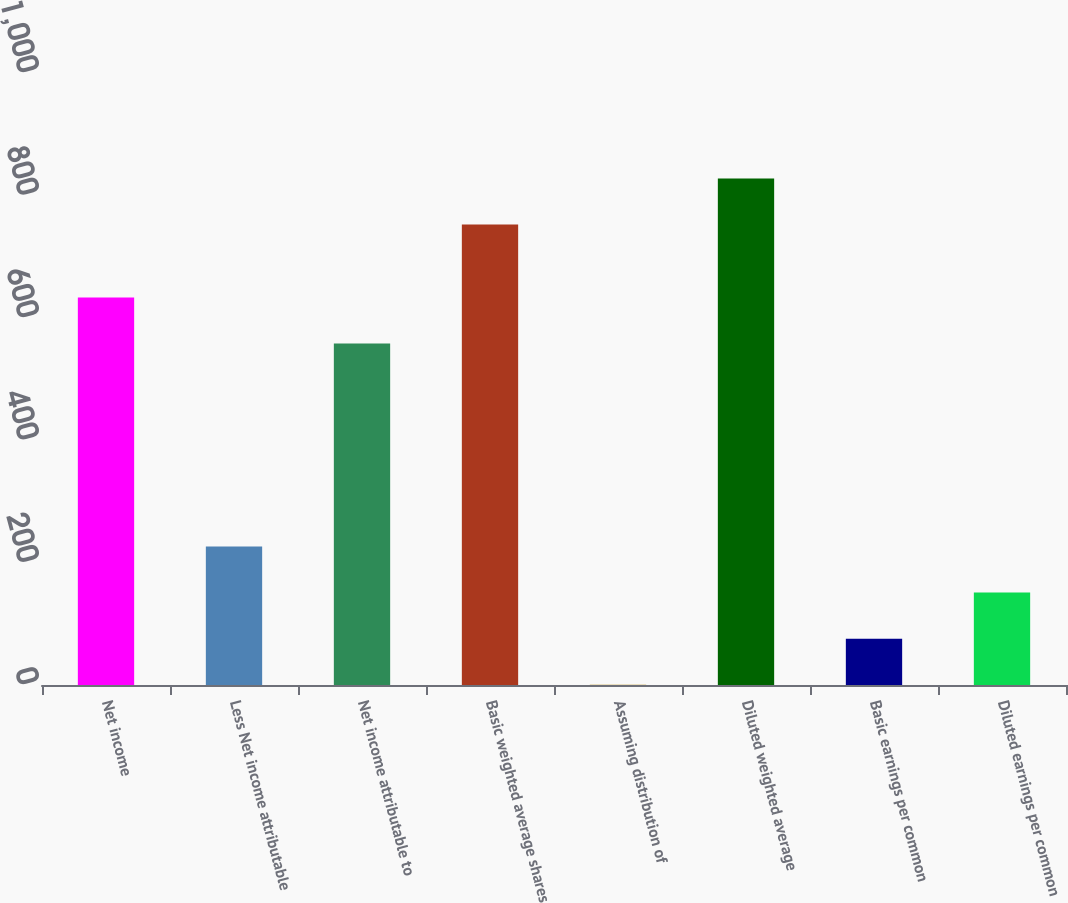Convert chart to OTSL. <chart><loc_0><loc_0><loc_500><loc_500><bar_chart><fcel>Net income<fcel>Less Net income attributable<fcel>Net income attributable to<fcel>Basic weighted average shares<fcel>Assuming distribution of<fcel>Diluted weighted average<fcel>Basic earnings per common<fcel>Diluted earnings per common<nl><fcel>633.24<fcel>226.22<fcel>558<fcel>752.4<fcel>0.5<fcel>827.64<fcel>75.74<fcel>150.98<nl></chart> 